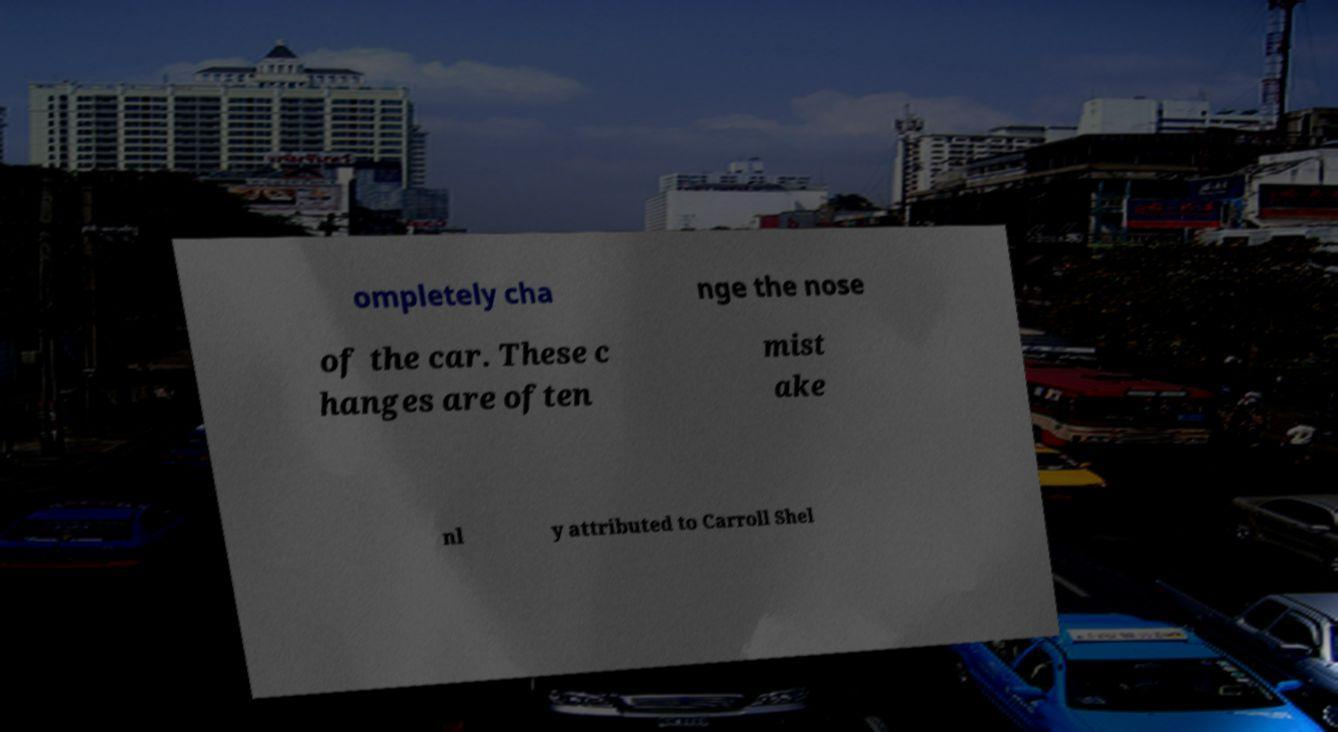Could you assist in decoding the text presented in this image and type it out clearly? ompletely cha nge the nose of the car. These c hanges are often mist ake nl y attributed to Carroll Shel 